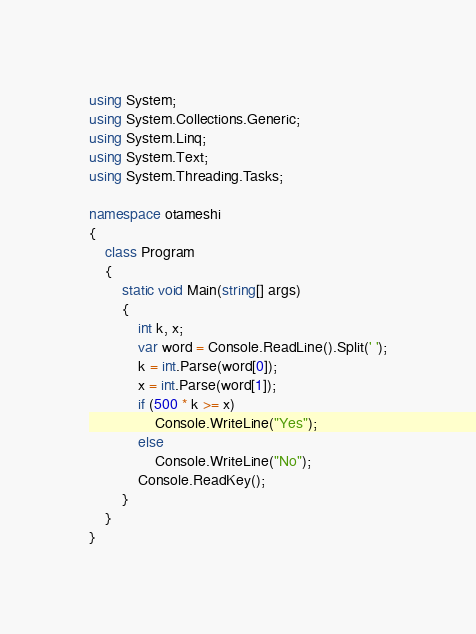<code> <loc_0><loc_0><loc_500><loc_500><_C#_>using System;
using System.Collections.Generic;
using System.Linq;
using System.Text;
using System.Threading.Tasks;

namespace otameshi
{
    class Program
    {
        static void Main(string[] args)
        {
            int k, x;
            var word = Console.ReadLine().Split(' ');
            k = int.Parse(word[0]);
            x = int.Parse(word[1]);
            if (500 * k >= x)
                Console.WriteLine("Yes");
            else
                Console.WriteLine("No");
            Console.ReadKey();
        }
    }
}
</code> 